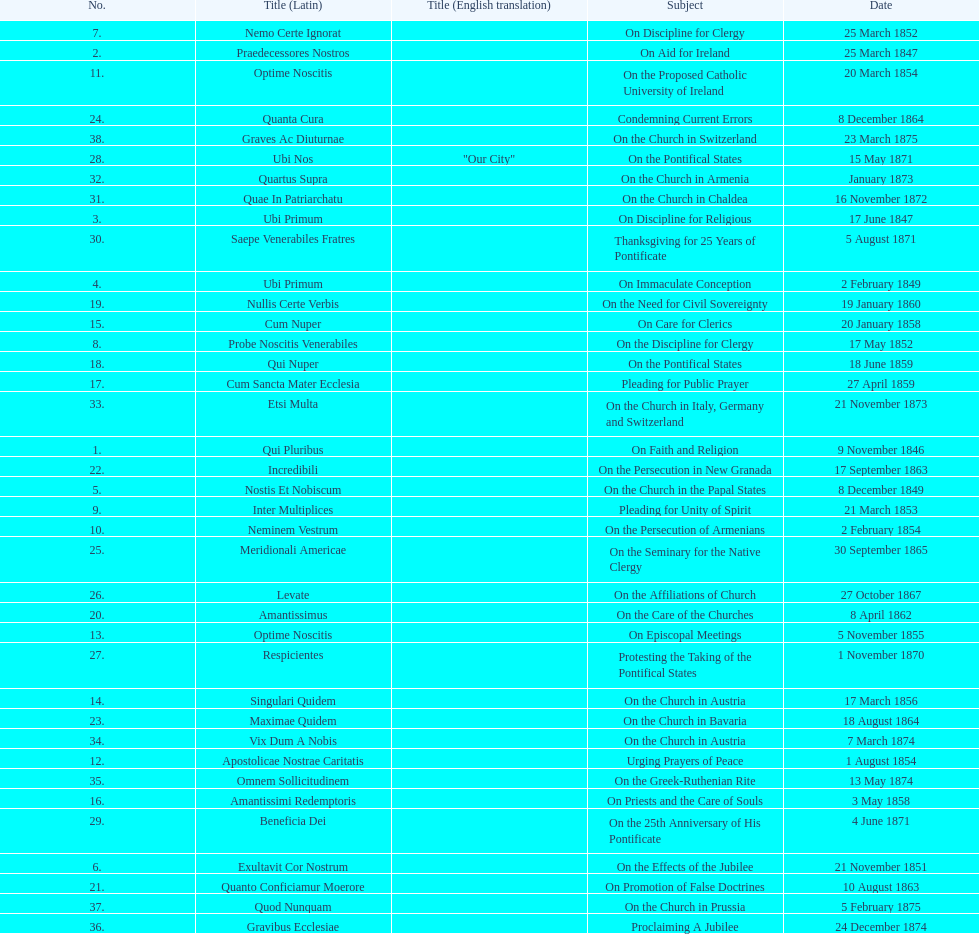How often was an encyclical sent in january? 3. 